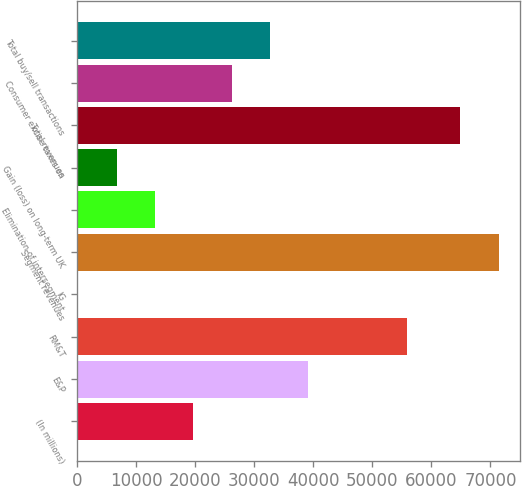<chart> <loc_0><loc_0><loc_500><loc_500><bar_chart><fcel>(In millions)<fcel>E&P<fcel>RM&T<fcel>IG<fcel>Segment revenues<fcel>Elimination of intersegment<fcel>Gain (loss) on long-term UK<fcel>Total revenues<fcel>Consumer excise taxes on<fcel>Total buy/sell transactions<nl><fcel>19664.3<fcel>39149.6<fcel>55941<fcel>179<fcel>71391.1<fcel>13169.2<fcel>6674.1<fcel>64896<fcel>26159.4<fcel>32654.5<nl></chart> 